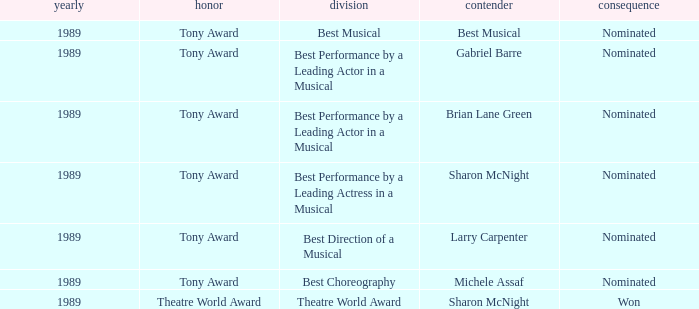What was the nominee of best musical Best Musical. 